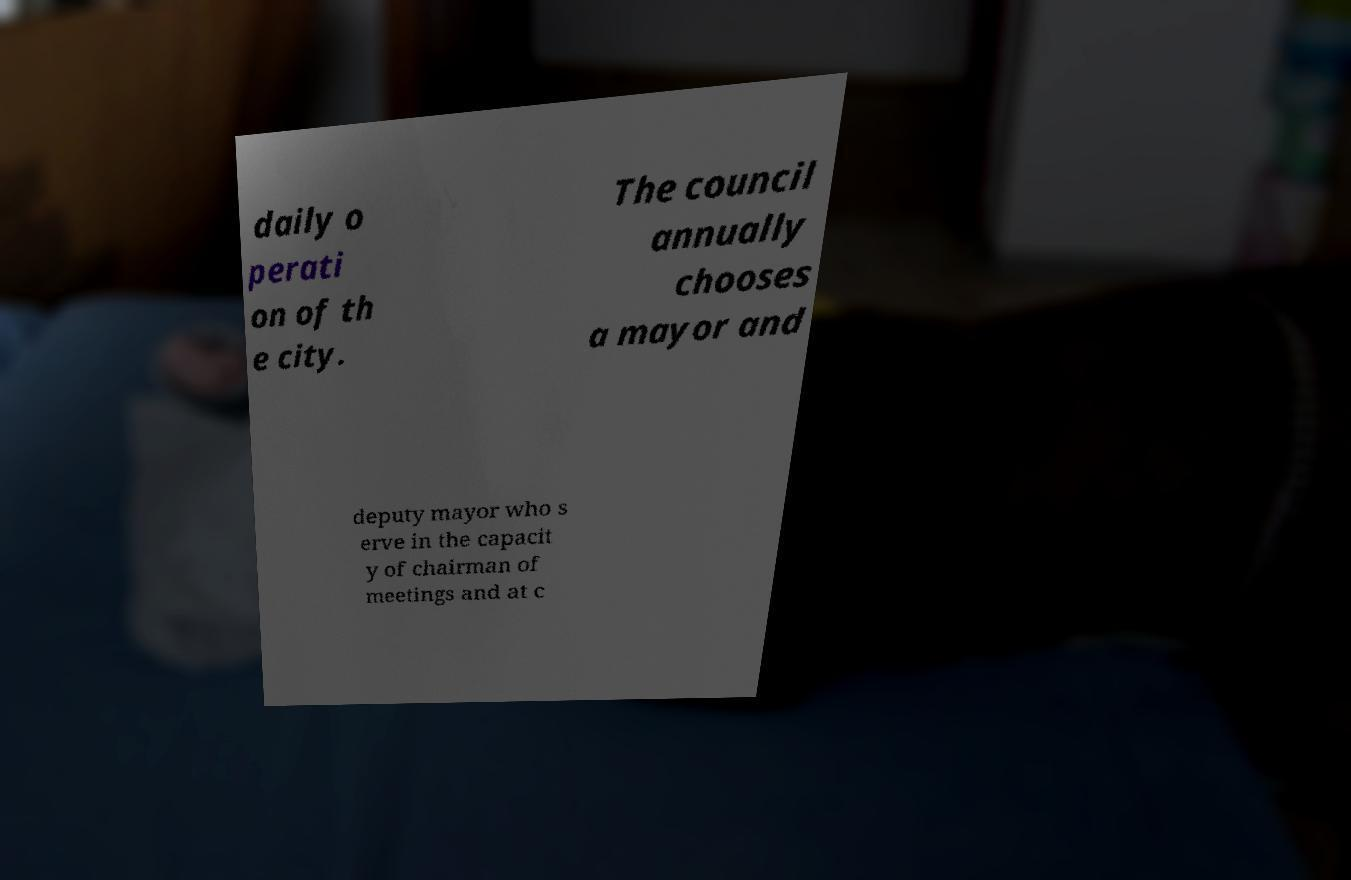Can you accurately transcribe the text from the provided image for me? daily o perati on of th e city. The council annually chooses a mayor and deputy mayor who s erve in the capacit y of chairman of meetings and at c 